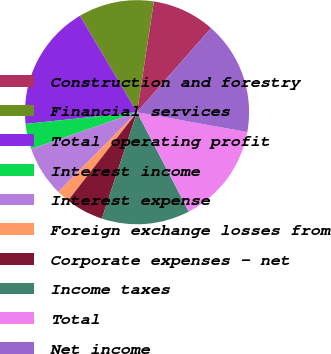Convert chart. <chart><loc_0><loc_0><loc_500><loc_500><pie_chart><fcel>Construction and forestry<fcel>Financial services<fcel>Total operating profit<fcel>Interest income<fcel>Interest expense<fcel>Foreign exchange losses from<fcel>Corporate expenses - net<fcel>Income taxes<fcel>Total<fcel>Net income<nl><fcel>9.09%<fcel>10.91%<fcel>18.16%<fcel>3.66%<fcel>7.28%<fcel>1.84%<fcel>5.47%<fcel>12.72%<fcel>14.53%<fcel>16.34%<nl></chart> 